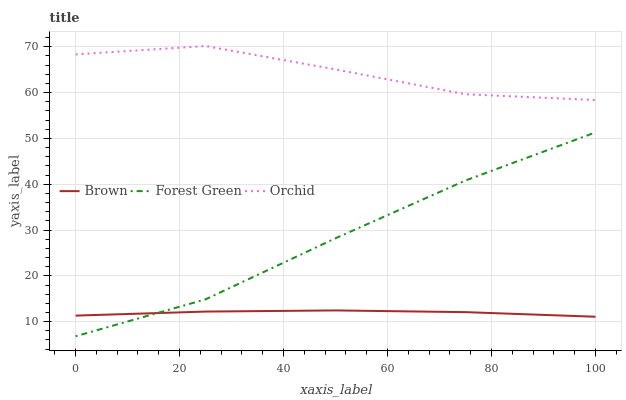Does Forest Green have the minimum area under the curve?
Answer yes or no. No. Does Forest Green have the maximum area under the curve?
Answer yes or no. No. Is Forest Green the smoothest?
Answer yes or no. No. Is Forest Green the roughest?
Answer yes or no. No. Does Orchid have the lowest value?
Answer yes or no. No. Does Forest Green have the highest value?
Answer yes or no. No. Is Brown less than Orchid?
Answer yes or no. Yes. Is Orchid greater than Forest Green?
Answer yes or no. Yes. Does Brown intersect Orchid?
Answer yes or no. No. 